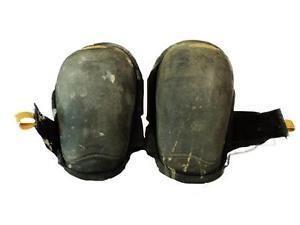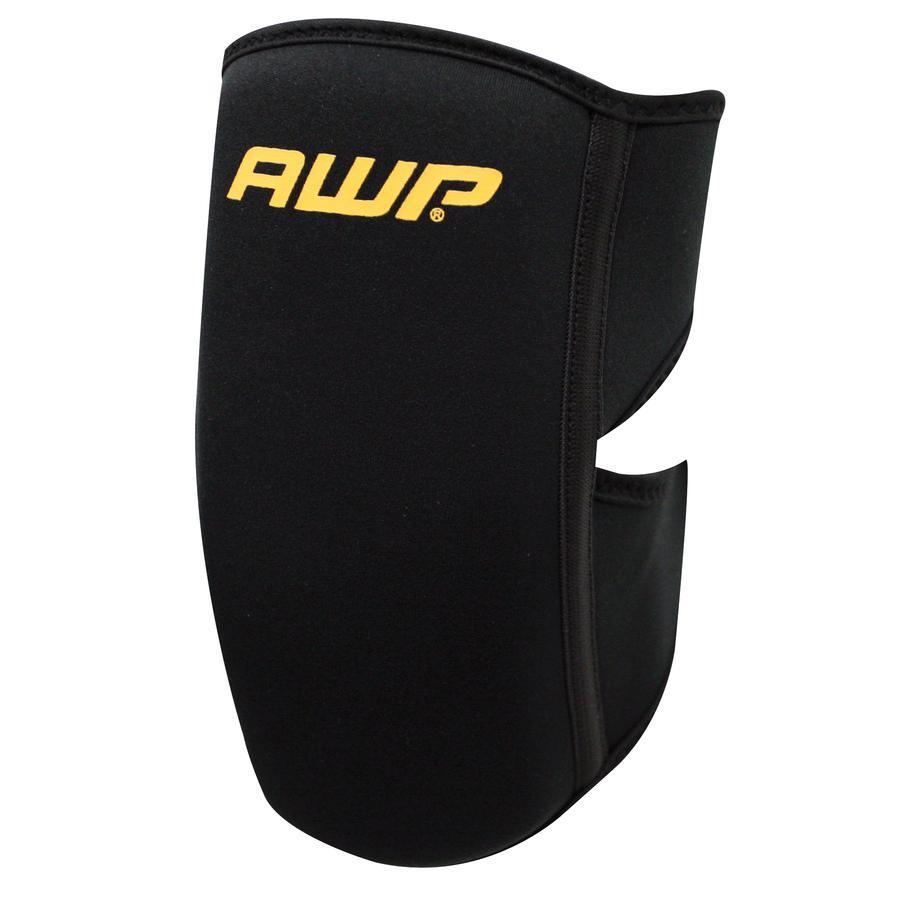The first image is the image on the left, the second image is the image on the right. Given the left and right images, does the statement "In the image on the right, you can clearly see the label that designates which knee this pad goes on." hold true? Answer yes or no. No. The first image is the image on the left, the second image is the image on the right. Evaluate the accuracy of this statement regarding the images: "At least one knee pad tells you which knee to put it on.". Is it true? Answer yes or no. No. 